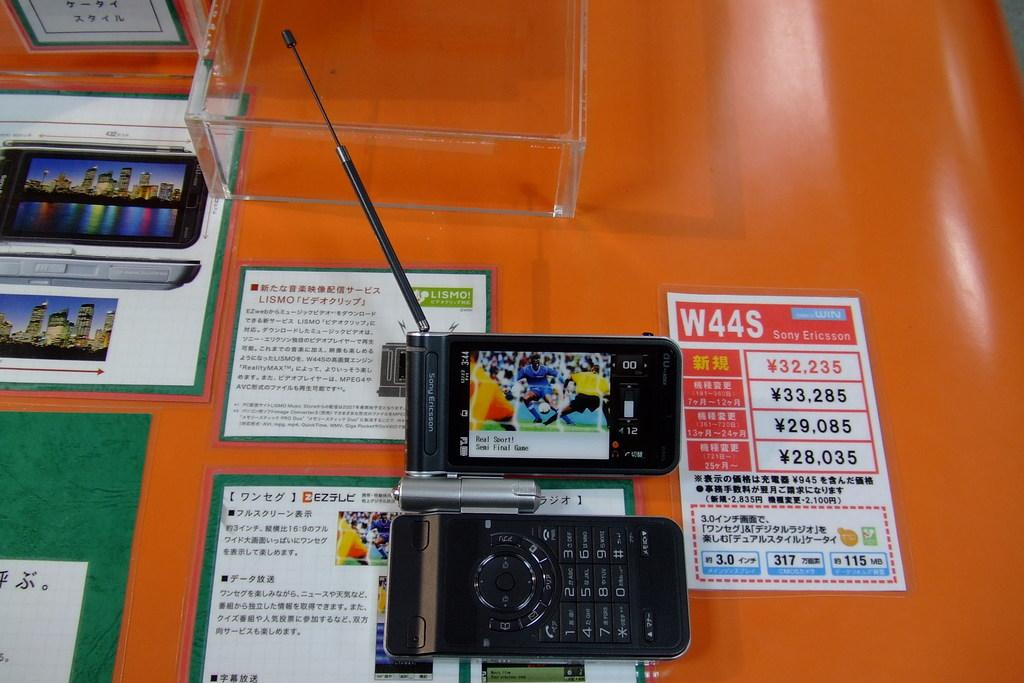<image>
Provide a brief description of the given image. a W44S paper that is on an orange surface 